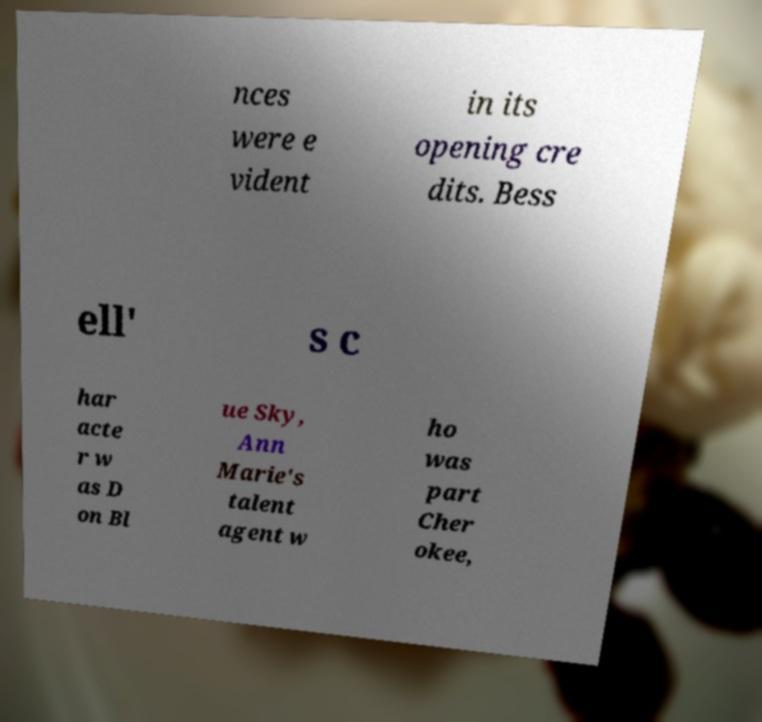I need the written content from this picture converted into text. Can you do that? nces were e vident in its opening cre dits. Bess ell' s c har acte r w as D on Bl ue Sky, Ann Marie's talent agent w ho was part Cher okee, 